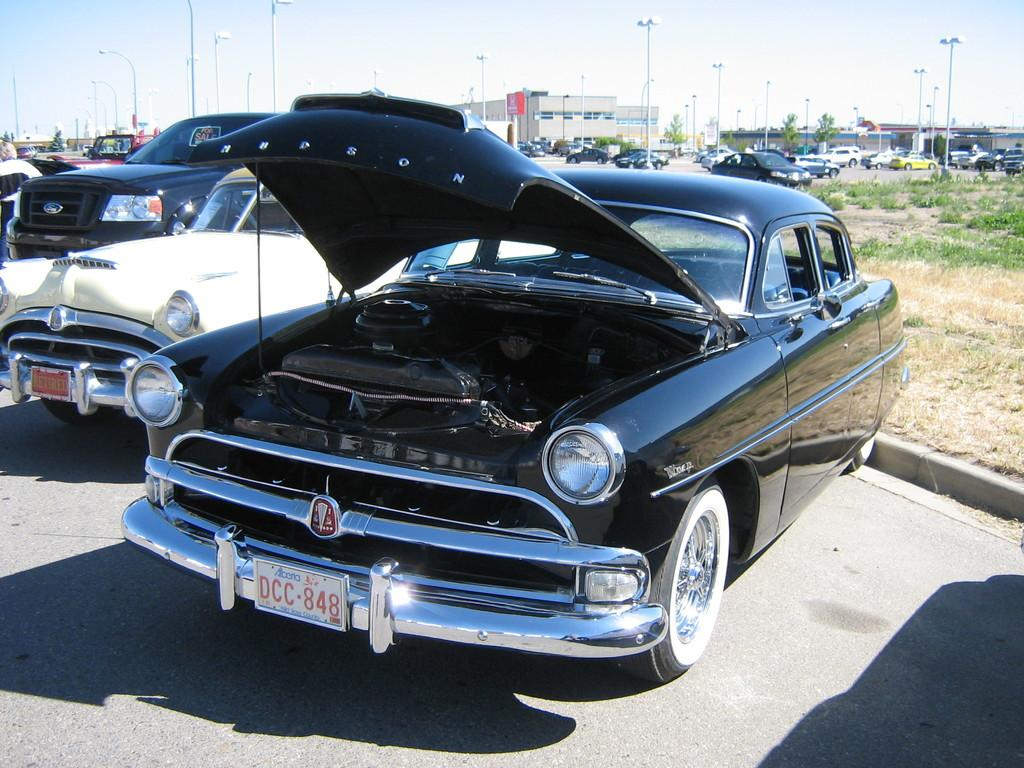What type of vehicles can be seen in the image? There are cars in the image. What structures are present in the image? There are poles and buildings in the image. What is visible in the background of the image? The sky is visible in the image. What type of vegetation is on the right side of the image? There is grass on the right side of the image. What can be observed on the ground in the image? Shadows are present on the ground. How many cakes are being served on the poles in the image? There are no cakes present in the image; it features cars, poles, buildings, grass, and shadows. What type of curve can be seen in the image? There is no curve visible in the image; it primarily consists of straight lines and angles. 